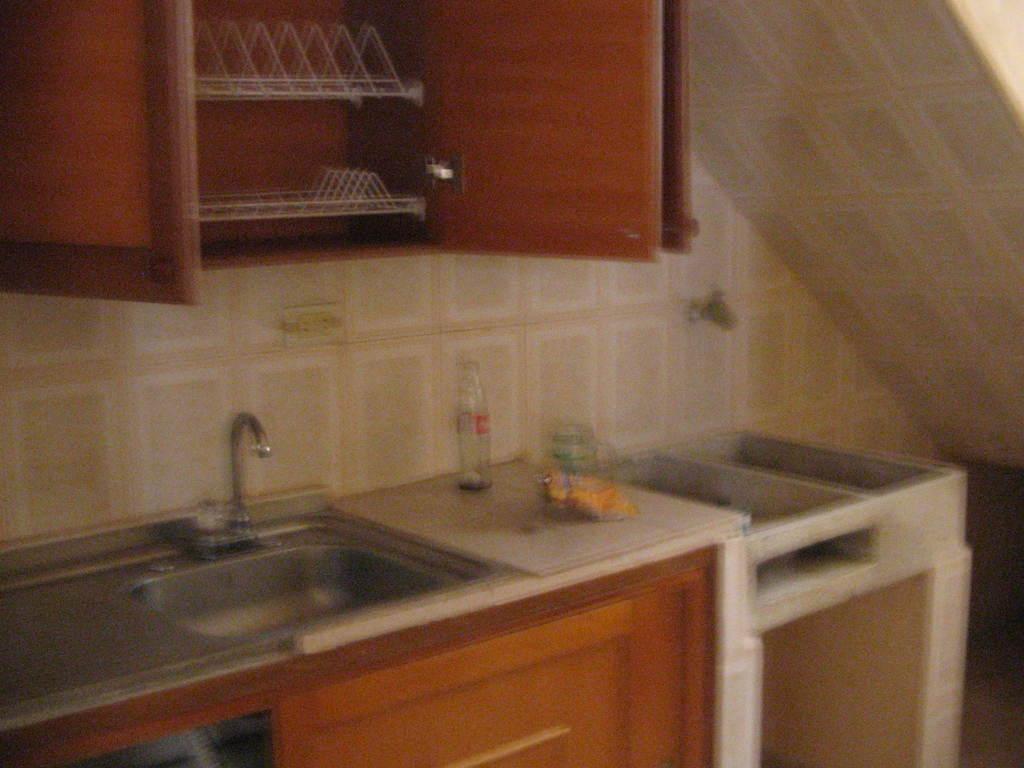Describe this image in one or two sentences. This picture is clicked inside. In the center there is a kitchen platform and we can see the bottles, washbasin and a tap. At the top there is a wall and a wooden cabinet. 